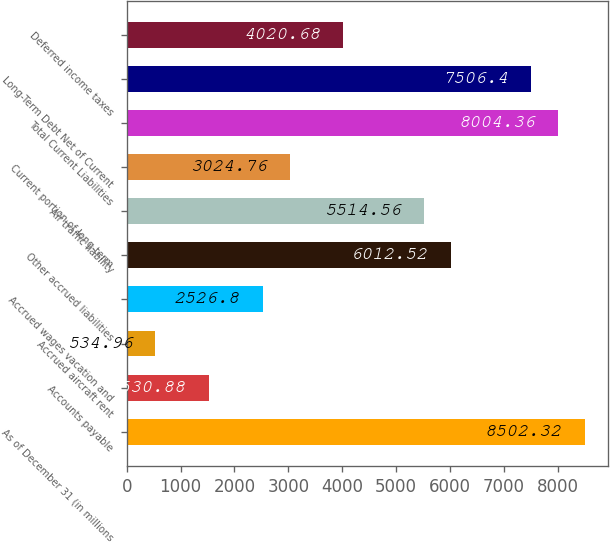Convert chart. <chart><loc_0><loc_0><loc_500><loc_500><bar_chart><fcel>As of December 31 (in millions<fcel>Accounts payable<fcel>Accrued aircraft rent<fcel>Accrued wages vacation and<fcel>Other accrued liabilities<fcel>Air traffic liability<fcel>Current portion of long-term<fcel>Total Current Liabilities<fcel>Long-Term Debt Net of Current<fcel>Deferred income taxes<nl><fcel>8502.32<fcel>1530.88<fcel>534.96<fcel>2526.8<fcel>6012.52<fcel>5514.56<fcel>3024.76<fcel>8004.36<fcel>7506.4<fcel>4020.68<nl></chart> 